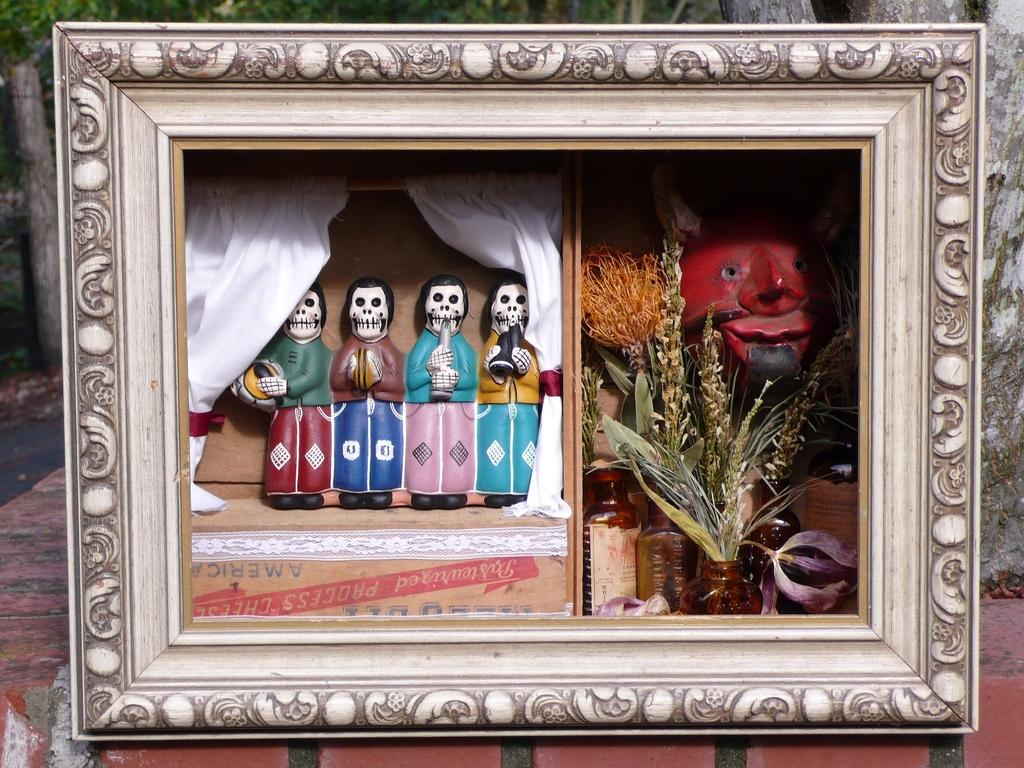What is the main object in the image? There is a photo frame in the image. What is inside the photo frame? The photo frame contains toys, jars, and plants. What is the photo frame placed on? The photo frame is on a red object. What can be seen in the background of the image? There are trees visible in the background of the image. How many quarters can be seen in the image? There are no quarters present in the image. What type of mine is visible in the background of the image? There is no mine visible in the image; it features trees in the background. 